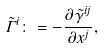<formula> <loc_0><loc_0><loc_500><loc_500>\tilde { \Gamma } ^ { i } \colon = - \frac { \partial \tilde { \gamma } ^ { i j } } { \partial x ^ { j } } ,</formula> 